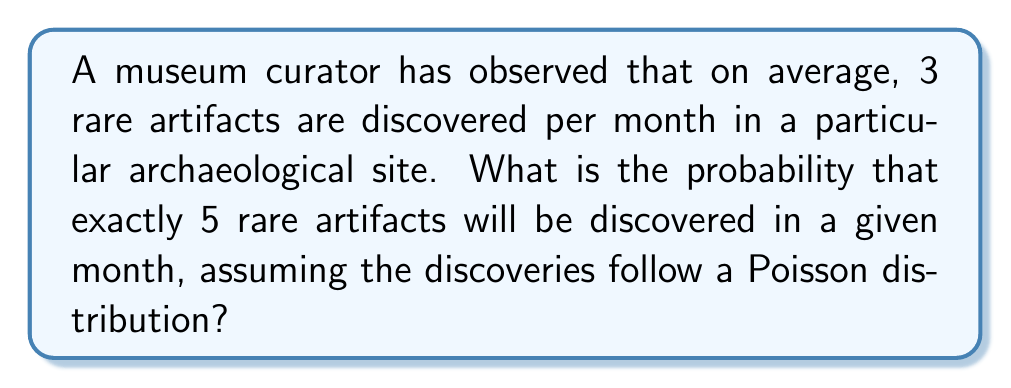What is the answer to this math problem? To solve this problem, we'll use the Poisson distribution formula:

$$P(X = k) = \frac{e^{-\lambda} \lambda^k}{k!}$$

Where:
$\lambda$ = average rate of occurrence (3 artifacts per month)
$k$ = number of occurrences we're calculating the probability for (5 artifacts)
$e$ = Euler's number (approximately 2.71828)

Let's substitute the values:

$$P(X = 5) = \frac{e^{-3} 3^5}{5!}$$

Now, let's calculate step-by-step:

1) First, calculate $e^{-3}$:
   $e^{-3} \approx 0.0497871$

2) Calculate $3^5$:
   $3^5 = 243$

3) Calculate $5!$:
   $5! = 5 \times 4 \times 3 \times 2 \times 1 = 120$

4) Now, put it all together:

   $$P(X = 5) = \frac{0.0497871 \times 243}{120}$$

5) Simplify:
   $$P(X = 5) = \frac{12.1042663}{120} \approx 0.1008689$$

6) Convert to a percentage:
   $0.1008689 \times 100\% \approx 10.09\%$
Answer: $10.09\%$ 